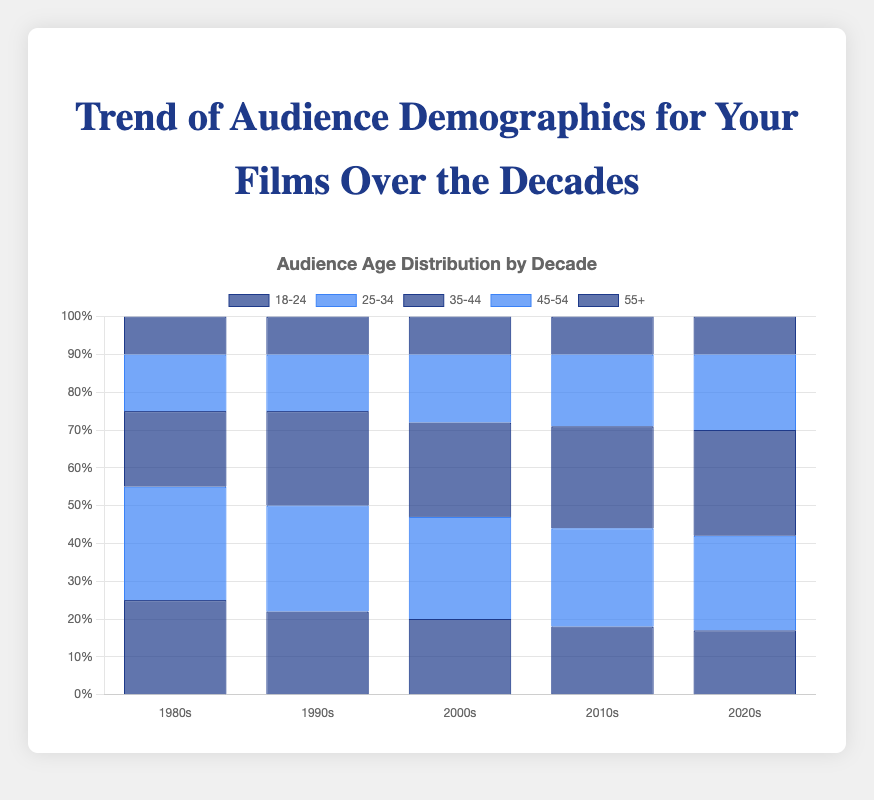What is the age group with the highest percentage in the 1980s? By examining the height of the bars for each age group in the 1980s, the age group with the highest bar indicates the highest percentage. The "25-34" bar is the tallest, showing the highest percentage in the 1980s.
Answer: 25-34 How does the percentage of the 18-24 age group in the 2020s compare to that in the 1980s? By comparing the heights of the "18-24" bars for the 2020s and the 1980s, we see that the bar for the 1980s is taller than the one for the 2020s. The percentage decreased from 25% in the 1980s to 17% in the 2020s.
Answer: The percentage decreased What's the average percentage of the 55+ age group over all decades? Sum the percentages of the "55+" age group for all decades (10 + 10 + 10 + 10 + 10) and divide by the number of decades (5). This gives (10 + 10 + 10 + 10 + 10) / 5 = 10%.
Answer: 10% Which age group shows the most consistent percentage across the decades? By observing the heights of the bars for each age group across all decades, we see that the "55+" age group has bars of almost equal height, indicating a consistent percentage.
Answer: 55+ Which decade has the highest percentage of the 35-44 age group? By examining the heights of the "35-44" bars across all decades, the tallest bar appears in the 2020s, indicating the highest percentage.
Answer: 2020s What is the percentage difference of the 18-24 age group between the 1990s and 2010s? Subtract the percentage of the 18-24 age group in the 2010s (18%) from that in the 1990s (22%). The difference is 22 - 18 = 4%.
Answer: 4% How does the sum of percentages for the 25-34 and 35-44 age groups in the 2000s compare to that in the 2020s? In the 2000s, the sum is 27% (25-34) + 25% (35-44) = 52%. In the 2020s, the sum is 25% (25-34) + 28% (35-44) = 53%. Comparing these, the sum is slightly higher in the 2020s.
Answer: 2020s In which decade does the 45-54 age group show the most substantial increase compared to the 1980s? Compare the 45-54 percentages across all decades to the 1980s (15%). The highest percentage for this age group is in the 2020s at 20%, which is a 5% increase.
Answer: 2020s Which two age groups have their highest percentage in the 2010s? By examining the bar heights for the 2010s, the age groups "35-44" and "45-54" both have their highest percentages in this decade at 27% and 19% respectively.
Answer: 35-44 and 45-54 Analyze the trend for the 25-34 age group from the 1980s to the 2020s. Observe the bar heights for the 25-34 age group: 30% (1980s), 28% (1990s), 27% (2000s), 26% (2010s), 25% (2020s). The trend shows a gradual decrease in percentage over the decades.
Answer: Decreasing 